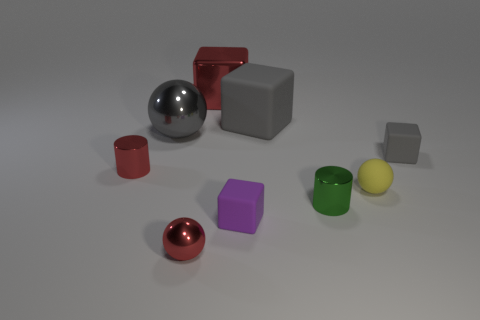Are there more matte balls behind the large ball than tiny green cylinders that are left of the small green metallic thing?
Offer a very short reply. No. Is the red thing that is behind the gray metal object made of the same material as the cube that is to the right of the large rubber block?
Your response must be concise. No. There is a metallic block; are there any tiny matte things in front of it?
Make the answer very short. Yes. How many blue objects are small rubber objects or spheres?
Offer a terse response. 0. Is the small red sphere made of the same material as the small block that is behind the yellow matte sphere?
Provide a short and direct response. No. What size is the gray metal object that is the same shape as the yellow matte thing?
Your answer should be compact. Large. What material is the small green thing?
Your answer should be compact. Metal. The ball that is behind the gray matte block in front of the gray shiny ball behind the green metal thing is made of what material?
Provide a short and direct response. Metal. Do the metallic cylinder that is on the left side of the large red thing and the red metallic object behind the large matte block have the same size?
Offer a terse response. No. What number of other objects are the same material as the big gray cube?
Keep it short and to the point. 3. 